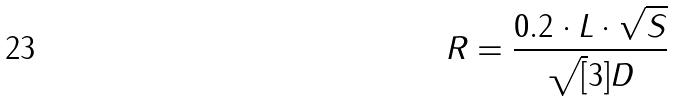<formula> <loc_0><loc_0><loc_500><loc_500>R = \frac { 0 . 2 \cdot L \cdot \sqrt { S } } { \sqrt { [ } 3 ] { D } }</formula> 